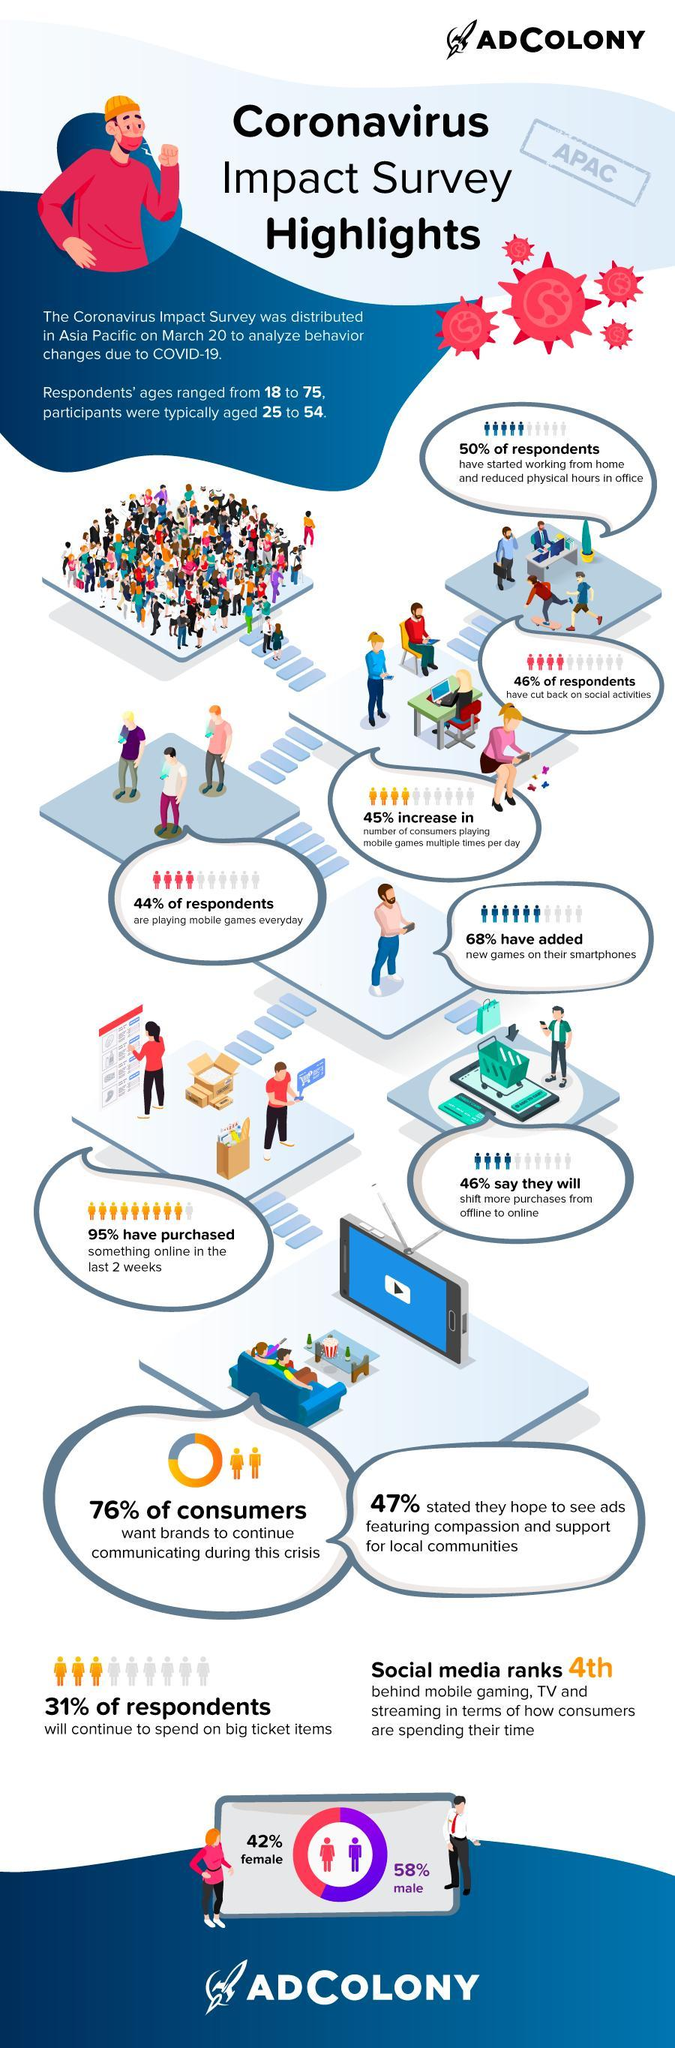What percentage of respondents have engaged in online buying?
Answer the question with a short phrase. 95% What percent of respondents will continue to spend on big ticket items? 31% What percentage of respondents want, compassionate and supportive ads, for local communities? 47% What percentage of consumers 'do not' expect brands to continue communicating during the crisis? 24% Which are the top three ways in which consumers are spending their time? Mobile gaming, TV and streaming How many word-bubbles are shown here? 9 What percentage of respondents are females? 42% What percent have installed new games on their smartphones? 68% What percentage of respondents still engage in social activities? 54% What percent of respondents, 'do not' intend to shift from offline to online mode of purchase? 54% 